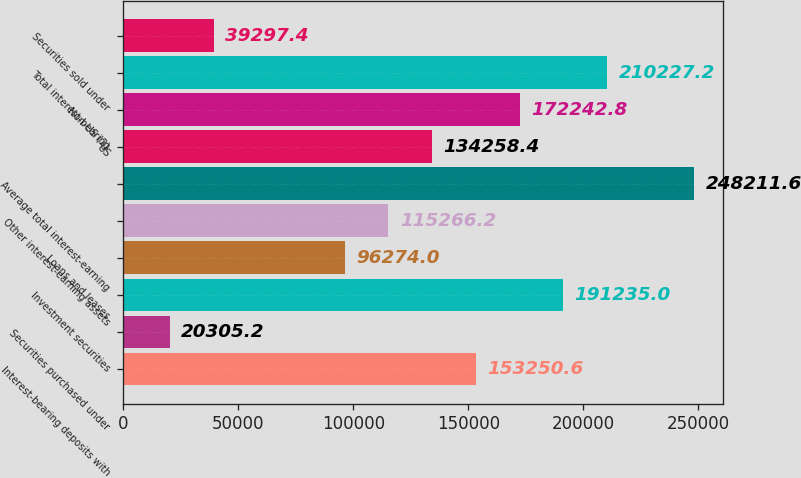Convert chart. <chart><loc_0><loc_0><loc_500><loc_500><bar_chart><fcel>Interest-bearing deposits with<fcel>Securities purchased under<fcel>Investment securities<fcel>Loans and leases<fcel>Other interest-earning assets<fcel>Average total interest-earning<fcel>US<fcel>Non-US (2)<fcel>Total interest-bearing<fcel>Securities sold under<nl><fcel>153251<fcel>20305.2<fcel>191235<fcel>96274<fcel>115266<fcel>248212<fcel>134258<fcel>172243<fcel>210227<fcel>39297.4<nl></chart> 